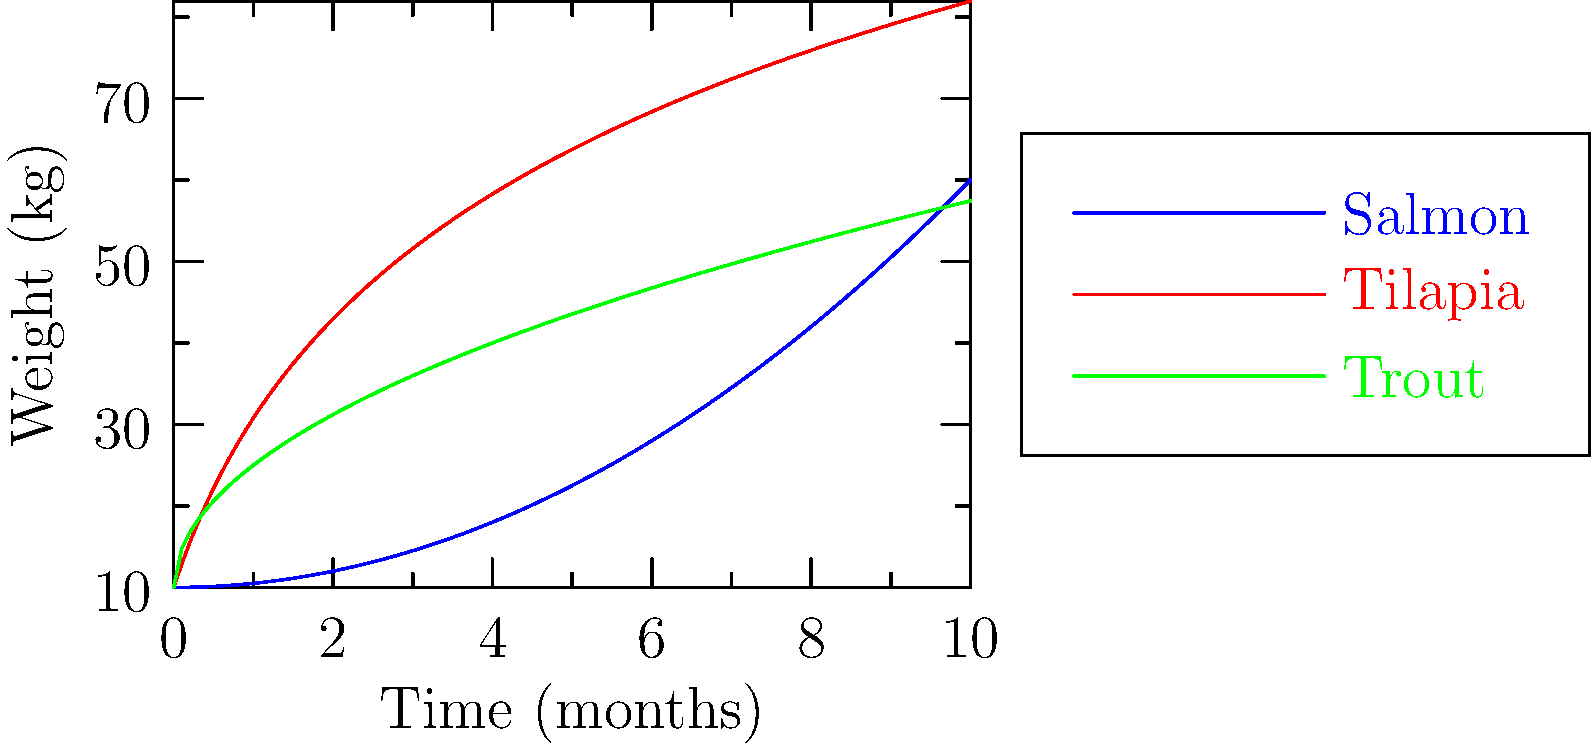Based on the growth curves shown in the graph, which fish species exhibits the most rapid growth in the later stages of the aquaculture cycle, and how might this impact the economic viability of farming this species? To answer this question, we need to analyze the growth curves of the three fish species:

1. Observe the slopes of each curve, particularly in the latter half of the graph (5-10 months):
   - Salmon (blue): The curve becomes steeper over time, indicating accelerating growth.
   - Tilapia (red): The curve flattens out, showing decelerating growth.
   - Trout (green): The curve's slope decreases slightly, indicating slowing growth.

2. Compare the final weights at 10 months:
   - Salmon reaches the highest weight, approximately 60 kg.
   - Tilapia and Trout both reach about 40-45 kg.

3. Analyze the growth rate in the later stages:
   - Salmon's growth rate increases significantly after 5 months.
   - Tilapia and Trout growth rates slow down after 5 months.

4. Economic implications:
   - Faster growth in later stages means shorter time to market weight.
   - Higher final weight potentially means more marketable product per fish.
   - Accelerating growth could lead to more efficient feed conversion in later stages.

Given these observations, Salmon exhibits the most rapid growth in the later stages of the aquaculture cycle.

The economic viability of farming Salmon could be positively impacted due to:
   a) Potential for shorter production cycles
   b) Higher yield per fish
   c) Possibly improved feed conversion efficiency in later stages

However, it's important to note that other factors such as input costs, market prices, and environmental considerations would also play crucial roles in determining overall economic viability.
Answer: Salmon; faster growth in later stages potentially reduces production time and increases yield per fish, improving economic viability. 